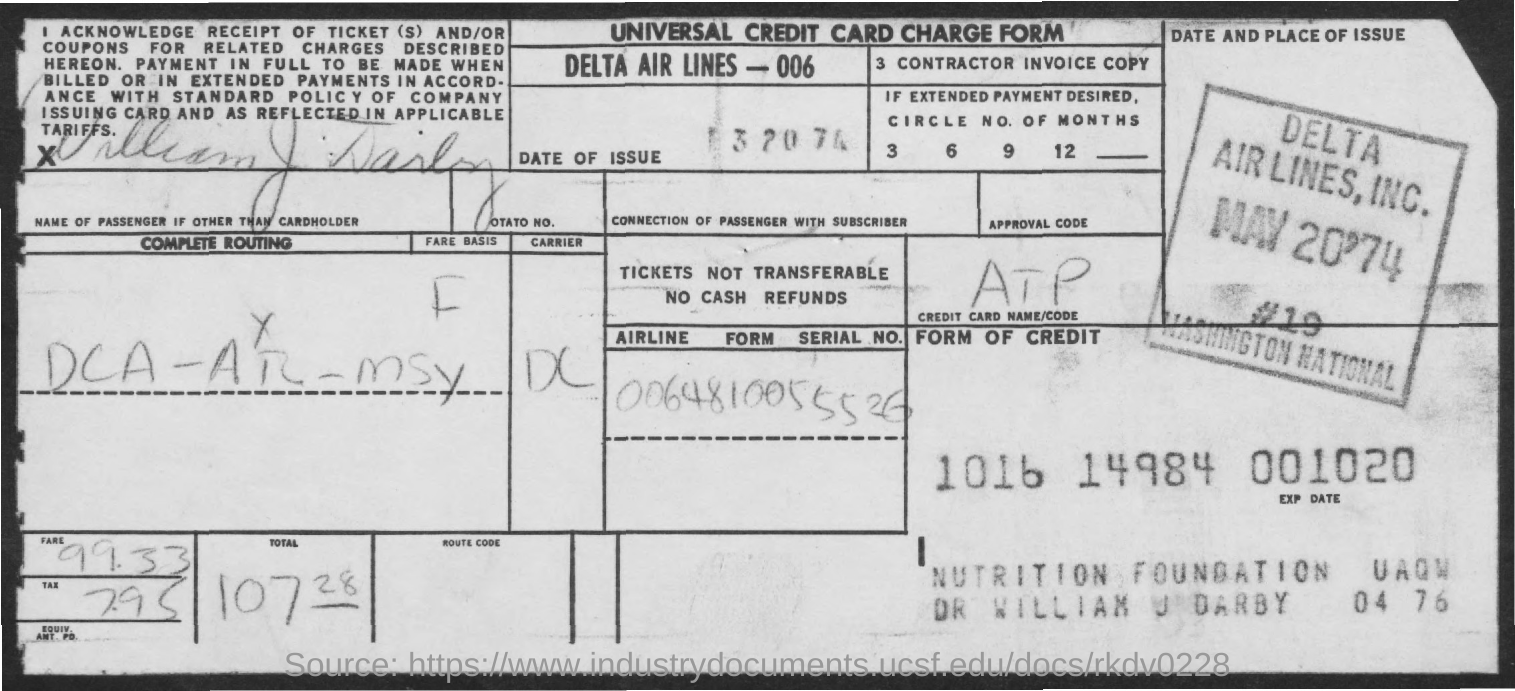Outline some significant characteristics in this image. Delta Air Lines is the name of an airline. The form named "Universal Credit Card Charge" is the name of the form given. 